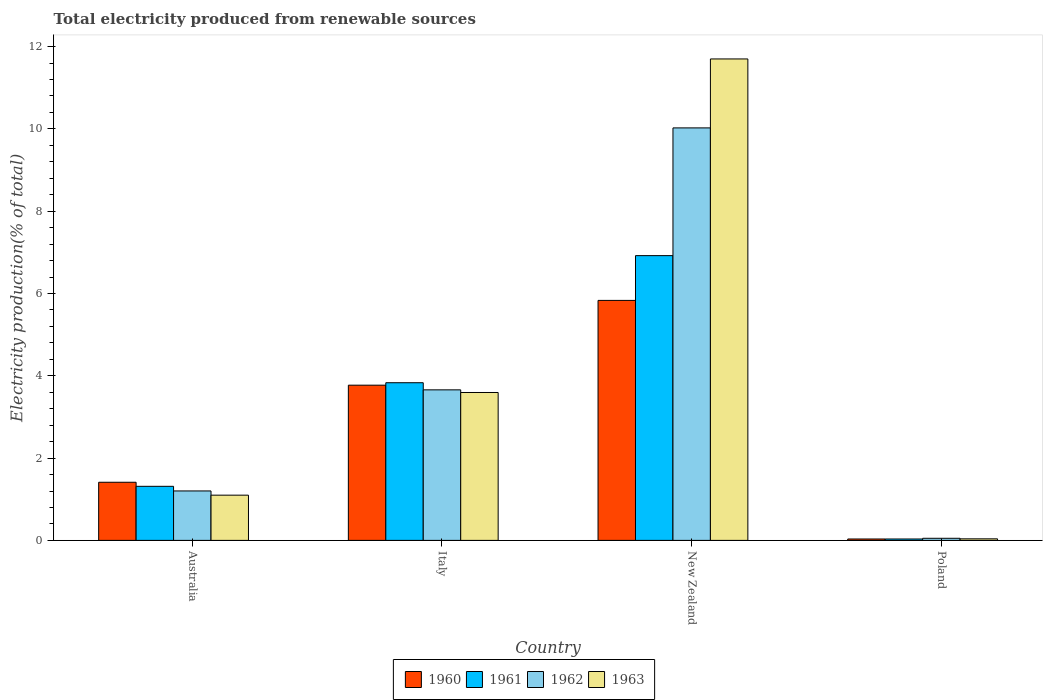How many different coloured bars are there?
Give a very brief answer. 4. How many groups of bars are there?
Your answer should be compact. 4. Are the number of bars per tick equal to the number of legend labels?
Make the answer very short. Yes. How many bars are there on the 2nd tick from the right?
Keep it short and to the point. 4. What is the label of the 4th group of bars from the left?
Your response must be concise. Poland. In how many cases, is the number of bars for a given country not equal to the number of legend labels?
Give a very brief answer. 0. What is the total electricity produced in 1962 in Poland?
Offer a terse response. 0.05. Across all countries, what is the maximum total electricity produced in 1962?
Your response must be concise. 10.02. Across all countries, what is the minimum total electricity produced in 1961?
Your response must be concise. 0.03. In which country was the total electricity produced in 1961 maximum?
Ensure brevity in your answer.  New Zealand. In which country was the total electricity produced in 1962 minimum?
Your answer should be very brief. Poland. What is the total total electricity produced in 1961 in the graph?
Offer a terse response. 12.1. What is the difference between the total electricity produced in 1962 in Australia and that in Poland?
Offer a very short reply. 1.15. What is the difference between the total electricity produced in 1963 in New Zealand and the total electricity produced in 1962 in Poland?
Ensure brevity in your answer.  11.65. What is the average total electricity produced in 1963 per country?
Offer a terse response. 4.11. What is the difference between the total electricity produced of/in 1961 and total electricity produced of/in 1963 in Australia?
Ensure brevity in your answer.  0.21. What is the ratio of the total electricity produced in 1962 in Australia to that in Italy?
Your answer should be very brief. 0.33. Is the difference between the total electricity produced in 1961 in Australia and Poland greater than the difference between the total electricity produced in 1963 in Australia and Poland?
Offer a very short reply. Yes. What is the difference between the highest and the second highest total electricity produced in 1961?
Make the answer very short. -2.52. What is the difference between the highest and the lowest total electricity produced in 1962?
Ensure brevity in your answer.  9.97. Is the sum of the total electricity produced in 1960 in New Zealand and Poland greater than the maximum total electricity produced in 1961 across all countries?
Your response must be concise. No. What does the 2nd bar from the left in New Zealand represents?
Provide a short and direct response. 1961. What does the 2nd bar from the right in Italy represents?
Offer a terse response. 1962. Is it the case that in every country, the sum of the total electricity produced in 1962 and total electricity produced in 1961 is greater than the total electricity produced in 1960?
Your answer should be very brief. Yes. Are all the bars in the graph horizontal?
Your answer should be very brief. No. What is the difference between two consecutive major ticks on the Y-axis?
Offer a very short reply. 2. Does the graph contain grids?
Offer a terse response. No. What is the title of the graph?
Provide a short and direct response. Total electricity produced from renewable sources. What is the label or title of the Y-axis?
Your answer should be compact. Electricity production(% of total). What is the Electricity production(% of total) in 1960 in Australia?
Your answer should be very brief. 1.41. What is the Electricity production(% of total) in 1961 in Australia?
Provide a short and direct response. 1.31. What is the Electricity production(% of total) of 1962 in Australia?
Offer a terse response. 1.2. What is the Electricity production(% of total) of 1963 in Australia?
Make the answer very short. 1.1. What is the Electricity production(% of total) of 1960 in Italy?
Give a very brief answer. 3.77. What is the Electricity production(% of total) in 1961 in Italy?
Make the answer very short. 3.83. What is the Electricity production(% of total) in 1962 in Italy?
Your answer should be compact. 3.66. What is the Electricity production(% of total) of 1963 in Italy?
Offer a very short reply. 3.59. What is the Electricity production(% of total) of 1960 in New Zealand?
Offer a terse response. 5.83. What is the Electricity production(% of total) in 1961 in New Zealand?
Offer a terse response. 6.92. What is the Electricity production(% of total) of 1962 in New Zealand?
Provide a succinct answer. 10.02. What is the Electricity production(% of total) in 1963 in New Zealand?
Offer a terse response. 11.7. What is the Electricity production(% of total) of 1960 in Poland?
Ensure brevity in your answer.  0.03. What is the Electricity production(% of total) of 1961 in Poland?
Your response must be concise. 0.03. What is the Electricity production(% of total) in 1962 in Poland?
Provide a short and direct response. 0.05. What is the Electricity production(% of total) in 1963 in Poland?
Ensure brevity in your answer.  0.04. Across all countries, what is the maximum Electricity production(% of total) of 1960?
Provide a short and direct response. 5.83. Across all countries, what is the maximum Electricity production(% of total) in 1961?
Offer a terse response. 6.92. Across all countries, what is the maximum Electricity production(% of total) in 1962?
Offer a terse response. 10.02. Across all countries, what is the maximum Electricity production(% of total) in 1963?
Give a very brief answer. 11.7. Across all countries, what is the minimum Electricity production(% of total) in 1960?
Keep it short and to the point. 0.03. Across all countries, what is the minimum Electricity production(% of total) of 1961?
Provide a short and direct response. 0.03. Across all countries, what is the minimum Electricity production(% of total) of 1962?
Your answer should be compact. 0.05. Across all countries, what is the minimum Electricity production(% of total) in 1963?
Offer a very short reply. 0.04. What is the total Electricity production(% of total) in 1960 in the graph?
Offer a terse response. 11.05. What is the total Electricity production(% of total) of 1962 in the graph?
Provide a succinct answer. 14.94. What is the total Electricity production(% of total) of 1963 in the graph?
Your answer should be compact. 16.43. What is the difference between the Electricity production(% of total) of 1960 in Australia and that in Italy?
Provide a short and direct response. -2.36. What is the difference between the Electricity production(% of total) in 1961 in Australia and that in Italy?
Your answer should be compact. -2.52. What is the difference between the Electricity production(% of total) in 1962 in Australia and that in Italy?
Give a very brief answer. -2.46. What is the difference between the Electricity production(% of total) of 1963 in Australia and that in Italy?
Give a very brief answer. -2.5. What is the difference between the Electricity production(% of total) of 1960 in Australia and that in New Zealand?
Give a very brief answer. -4.42. What is the difference between the Electricity production(% of total) of 1961 in Australia and that in New Zealand?
Provide a succinct answer. -5.61. What is the difference between the Electricity production(% of total) in 1962 in Australia and that in New Zealand?
Offer a terse response. -8.82. What is the difference between the Electricity production(% of total) of 1963 in Australia and that in New Zealand?
Ensure brevity in your answer.  -10.6. What is the difference between the Electricity production(% of total) in 1960 in Australia and that in Poland?
Your response must be concise. 1.38. What is the difference between the Electricity production(% of total) of 1961 in Australia and that in Poland?
Your answer should be compact. 1.28. What is the difference between the Electricity production(% of total) of 1962 in Australia and that in Poland?
Keep it short and to the point. 1.15. What is the difference between the Electricity production(% of total) of 1963 in Australia and that in Poland?
Your answer should be compact. 1.06. What is the difference between the Electricity production(% of total) of 1960 in Italy and that in New Zealand?
Keep it short and to the point. -2.06. What is the difference between the Electricity production(% of total) of 1961 in Italy and that in New Zealand?
Your answer should be compact. -3.09. What is the difference between the Electricity production(% of total) of 1962 in Italy and that in New Zealand?
Provide a short and direct response. -6.37. What is the difference between the Electricity production(% of total) in 1963 in Italy and that in New Zealand?
Give a very brief answer. -8.11. What is the difference between the Electricity production(% of total) of 1960 in Italy and that in Poland?
Keep it short and to the point. 3.74. What is the difference between the Electricity production(% of total) in 1961 in Italy and that in Poland?
Your response must be concise. 3.8. What is the difference between the Electricity production(% of total) of 1962 in Italy and that in Poland?
Make the answer very short. 3.61. What is the difference between the Electricity production(% of total) of 1963 in Italy and that in Poland?
Provide a short and direct response. 3.56. What is the difference between the Electricity production(% of total) in 1960 in New Zealand and that in Poland?
Provide a succinct answer. 5.8. What is the difference between the Electricity production(% of total) of 1961 in New Zealand and that in Poland?
Your answer should be very brief. 6.89. What is the difference between the Electricity production(% of total) of 1962 in New Zealand and that in Poland?
Your answer should be compact. 9.97. What is the difference between the Electricity production(% of total) in 1963 in New Zealand and that in Poland?
Offer a terse response. 11.66. What is the difference between the Electricity production(% of total) in 1960 in Australia and the Electricity production(% of total) in 1961 in Italy?
Offer a very short reply. -2.42. What is the difference between the Electricity production(% of total) of 1960 in Australia and the Electricity production(% of total) of 1962 in Italy?
Your response must be concise. -2.25. What is the difference between the Electricity production(% of total) of 1960 in Australia and the Electricity production(% of total) of 1963 in Italy?
Ensure brevity in your answer.  -2.18. What is the difference between the Electricity production(% of total) in 1961 in Australia and the Electricity production(% of total) in 1962 in Italy?
Your response must be concise. -2.34. What is the difference between the Electricity production(% of total) of 1961 in Australia and the Electricity production(% of total) of 1963 in Italy?
Give a very brief answer. -2.28. What is the difference between the Electricity production(% of total) of 1962 in Australia and the Electricity production(% of total) of 1963 in Italy?
Make the answer very short. -2.39. What is the difference between the Electricity production(% of total) of 1960 in Australia and the Electricity production(% of total) of 1961 in New Zealand?
Provide a succinct answer. -5.51. What is the difference between the Electricity production(% of total) of 1960 in Australia and the Electricity production(% of total) of 1962 in New Zealand?
Your response must be concise. -8.61. What is the difference between the Electricity production(% of total) of 1960 in Australia and the Electricity production(% of total) of 1963 in New Zealand?
Give a very brief answer. -10.29. What is the difference between the Electricity production(% of total) of 1961 in Australia and the Electricity production(% of total) of 1962 in New Zealand?
Provide a succinct answer. -8.71. What is the difference between the Electricity production(% of total) in 1961 in Australia and the Electricity production(% of total) in 1963 in New Zealand?
Your answer should be compact. -10.39. What is the difference between the Electricity production(% of total) in 1962 in Australia and the Electricity production(% of total) in 1963 in New Zealand?
Provide a succinct answer. -10.5. What is the difference between the Electricity production(% of total) of 1960 in Australia and the Electricity production(% of total) of 1961 in Poland?
Offer a terse response. 1.38. What is the difference between the Electricity production(% of total) in 1960 in Australia and the Electricity production(% of total) in 1962 in Poland?
Your answer should be very brief. 1.36. What is the difference between the Electricity production(% of total) in 1960 in Australia and the Electricity production(% of total) in 1963 in Poland?
Ensure brevity in your answer.  1.37. What is the difference between the Electricity production(% of total) of 1961 in Australia and the Electricity production(% of total) of 1962 in Poland?
Give a very brief answer. 1.26. What is the difference between the Electricity production(% of total) of 1961 in Australia and the Electricity production(% of total) of 1963 in Poland?
Your answer should be very brief. 1.28. What is the difference between the Electricity production(% of total) in 1962 in Australia and the Electricity production(% of total) in 1963 in Poland?
Your answer should be very brief. 1.16. What is the difference between the Electricity production(% of total) of 1960 in Italy and the Electricity production(% of total) of 1961 in New Zealand?
Ensure brevity in your answer.  -3.15. What is the difference between the Electricity production(% of total) of 1960 in Italy and the Electricity production(% of total) of 1962 in New Zealand?
Your answer should be very brief. -6.25. What is the difference between the Electricity production(% of total) in 1960 in Italy and the Electricity production(% of total) in 1963 in New Zealand?
Your answer should be very brief. -7.93. What is the difference between the Electricity production(% of total) in 1961 in Italy and the Electricity production(% of total) in 1962 in New Zealand?
Your answer should be very brief. -6.19. What is the difference between the Electricity production(% of total) of 1961 in Italy and the Electricity production(% of total) of 1963 in New Zealand?
Keep it short and to the point. -7.87. What is the difference between the Electricity production(% of total) of 1962 in Italy and the Electricity production(% of total) of 1963 in New Zealand?
Ensure brevity in your answer.  -8.04. What is the difference between the Electricity production(% of total) in 1960 in Italy and the Electricity production(% of total) in 1961 in Poland?
Your answer should be very brief. 3.74. What is the difference between the Electricity production(% of total) of 1960 in Italy and the Electricity production(% of total) of 1962 in Poland?
Make the answer very short. 3.72. What is the difference between the Electricity production(% of total) of 1960 in Italy and the Electricity production(% of total) of 1963 in Poland?
Your answer should be compact. 3.73. What is the difference between the Electricity production(% of total) of 1961 in Italy and the Electricity production(% of total) of 1962 in Poland?
Keep it short and to the point. 3.78. What is the difference between the Electricity production(% of total) of 1961 in Italy and the Electricity production(% of total) of 1963 in Poland?
Offer a very short reply. 3.79. What is the difference between the Electricity production(% of total) in 1962 in Italy and the Electricity production(% of total) in 1963 in Poland?
Make the answer very short. 3.62. What is the difference between the Electricity production(% of total) in 1960 in New Zealand and the Electricity production(% of total) in 1961 in Poland?
Provide a succinct answer. 5.8. What is the difference between the Electricity production(% of total) of 1960 in New Zealand and the Electricity production(% of total) of 1962 in Poland?
Give a very brief answer. 5.78. What is the difference between the Electricity production(% of total) in 1960 in New Zealand and the Electricity production(% of total) in 1963 in Poland?
Your answer should be compact. 5.79. What is the difference between the Electricity production(% of total) in 1961 in New Zealand and the Electricity production(% of total) in 1962 in Poland?
Give a very brief answer. 6.87. What is the difference between the Electricity production(% of total) of 1961 in New Zealand and the Electricity production(% of total) of 1963 in Poland?
Ensure brevity in your answer.  6.88. What is the difference between the Electricity production(% of total) in 1962 in New Zealand and the Electricity production(% of total) in 1963 in Poland?
Your response must be concise. 9.99. What is the average Electricity production(% of total) in 1960 per country?
Ensure brevity in your answer.  2.76. What is the average Electricity production(% of total) in 1961 per country?
Provide a succinct answer. 3.02. What is the average Electricity production(% of total) of 1962 per country?
Ensure brevity in your answer.  3.73. What is the average Electricity production(% of total) of 1963 per country?
Give a very brief answer. 4.11. What is the difference between the Electricity production(% of total) in 1960 and Electricity production(% of total) in 1961 in Australia?
Offer a very short reply. 0.1. What is the difference between the Electricity production(% of total) of 1960 and Electricity production(% of total) of 1962 in Australia?
Offer a terse response. 0.21. What is the difference between the Electricity production(% of total) in 1960 and Electricity production(% of total) in 1963 in Australia?
Provide a short and direct response. 0.31. What is the difference between the Electricity production(% of total) in 1961 and Electricity production(% of total) in 1962 in Australia?
Offer a very short reply. 0.11. What is the difference between the Electricity production(% of total) in 1961 and Electricity production(% of total) in 1963 in Australia?
Give a very brief answer. 0.21. What is the difference between the Electricity production(% of total) in 1962 and Electricity production(% of total) in 1963 in Australia?
Provide a succinct answer. 0.1. What is the difference between the Electricity production(% of total) in 1960 and Electricity production(% of total) in 1961 in Italy?
Make the answer very short. -0.06. What is the difference between the Electricity production(% of total) of 1960 and Electricity production(% of total) of 1962 in Italy?
Your answer should be compact. 0.11. What is the difference between the Electricity production(% of total) in 1960 and Electricity production(% of total) in 1963 in Italy?
Your answer should be compact. 0.18. What is the difference between the Electricity production(% of total) in 1961 and Electricity production(% of total) in 1962 in Italy?
Ensure brevity in your answer.  0.17. What is the difference between the Electricity production(% of total) of 1961 and Electricity production(% of total) of 1963 in Italy?
Your response must be concise. 0.24. What is the difference between the Electricity production(% of total) of 1962 and Electricity production(% of total) of 1963 in Italy?
Your answer should be very brief. 0.06. What is the difference between the Electricity production(% of total) in 1960 and Electricity production(% of total) in 1961 in New Zealand?
Provide a succinct answer. -1.09. What is the difference between the Electricity production(% of total) in 1960 and Electricity production(% of total) in 1962 in New Zealand?
Give a very brief answer. -4.19. What is the difference between the Electricity production(% of total) in 1960 and Electricity production(% of total) in 1963 in New Zealand?
Provide a short and direct response. -5.87. What is the difference between the Electricity production(% of total) of 1961 and Electricity production(% of total) of 1962 in New Zealand?
Offer a very short reply. -3.1. What is the difference between the Electricity production(% of total) of 1961 and Electricity production(% of total) of 1963 in New Zealand?
Ensure brevity in your answer.  -4.78. What is the difference between the Electricity production(% of total) of 1962 and Electricity production(% of total) of 1963 in New Zealand?
Your answer should be compact. -1.68. What is the difference between the Electricity production(% of total) of 1960 and Electricity production(% of total) of 1962 in Poland?
Your response must be concise. -0.02. What is the difference between the Electricity production(% of total) of 1960 and Electricity production(% of total) of 1963 in Poland?
Ensure brevity in your answer.  -0. What is the difference between the Electricity production(% of total) in 1961 and Electricity production(% of total) in 1962 in Poland?
Keep it short and to the point. -0.02. What is the difference between the Electricity production(% of total) in 1961 and Electricity production(% of total) in 1963 in Poland?
Your answer should be very brief. -0. What is the difference between the Electricity production(% of total) of 1962 and Electricity production(% of total) of 1963 in Poland?
Offer a terse response. 0.01. What is the ratio of the Electricity production(% of total) in 1960 in Australia to that in Italy?
Provide a short and direct response. 0.37. What is the ratio of the Electricity production(% of total) in 1961 in Australia to that in Italy?
Give a very brief answer. 0.34. What is the ratio of the Electricity production(% of total) in 1962 in Australia to that in Italy?
Make the answer very short. 0.33. What is the ratio of the Electricity production(% of total) in 1963 in Australia to that in Italy?
Make the answer very short. 0.31. What is the ratio of the Electricity production(% of total) of 1960 in Australia to that in New Zealand?
Provide a short and direct response. 0.24. What is the ratio of the Electricity production(% of total) in 1961 in Australia to that in New Zealand?
Make the answer very short. 0.19. What is the ratio of the Electricity production(% of total) of 1962 in Australia to that in New Zealand?
Ensure brevity in your answer.  0.12. What is the ratio of the Electricity production(% of total) of 1963 in Australia to that in New Zealand?
Offer a terse response. 0.09. What is the ratio of the Electricity production(% of total) in 1960 in Australia to that in Poland?
Your answer should be very brief. 41.37. What is the ratio of the Electricity production(% of total) of 1961 in Australia to that in Poland?
Your answer should be compact. 38.51. What is the ratio of the Electricity production(% of total) in 1962 in Australia to that in Poland?
Ensure brevity in your answer.  23.61. What is the ratio of the Electricity production(% of total) of 1963 in Australia to that in Poland?
Provide a short and direct response. 29. What is the ratio of the Electricity production(% of total) in 1960 in Italy to that in New Zealand?
Provide a short and direct response. 0.65. What is the ratio of the Electricity production(% of total) of 1961 in Italy to that in New Zealand?
Your answer should be compact. 0.55. What is the ratio of the Electricity production(% of total) in 1962 in Italy to that in New Zealand?
Your response must be concise. 0.36. What is the ratio of the Electricity production(% of total) in 1963 in Italy to that in New Zealand?
Keep it short and to the point. 0.31. What is the ratio of the Electricity production(% of total) of 1960 in Italy to that in Poland?
Your response must be concise. 110.45. What is the ratio of the Electricity production(% of total) in 1961 in Italy to that in Poland?
Keep it short and to the point. 112.3. What is the ratio of the Electricity production(% of total) in 1962 in Italy to that in Poland?
Your answer should be very brief. 71.88. What is the ratio of the Electricity production(% of total) in 1963 in Italy to that in Poland?
Your answer should be very brief. 94.84. What is the ratio of the Electricity production(% of total) of 1960 in New Zealand to that in Poland?
Make the answer very short. 170.79. What is the ratio of the Electricity production(% of total) of 1961 in New Zealand to that in Poland?
Offer a very short reply. 202.83. What is the ratio of the Electricity production(% of total) in 1962 in New Zealand to that in Poland?
Offer a very short reply. 196.95. What is the ratio of the Electricity production(% of total) in 1963 in New Zealand to that in Poland?
Your answer should be compact. 308.73. What is the difference between the highest and the second highest Electricity production(% of total) in 1960?
Your answer should be compact. 2.06. What is the difference between the highest and the second highest Electricity production(% of total) of 1961?
Make the answer very short. 3.09. What is the difference between the highest and the second highest Electricity production(% of total) of 1962?
Provide a succinct answer. 6.37. What is the difference between the highest and the second highest Electricity production(% of total) of 1963?
Your answer should be very brief. 8.11. What is the difference between the highest and the lowest Electricity production(% of total) in 1960?
Make the answer very short. 5.8. What is the difference between the highest and the lowest Electricity production(% of total) of 1961?
Offer a very short reply. 6.89. What is the difference between the highest and the lowest Electricity production(% of total) of 1962?
Offer a terse response. 9.97. What is the difference between the highest and the lowest Electricity production(% of total) in 1963?
Your response must be concise. 11.66. 